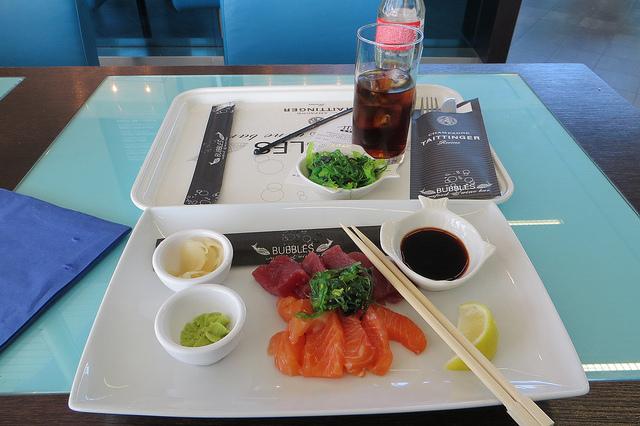What is the food called that is on the tray with the chopsticks on it?
Give a very brief answer. Sushi. What is ion the plate?
Concise answer only. Food. Is this a typical American food?
Quick response, please. No. 